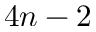<formula> <loc_0><loc_0><loc_500><loc_500>4 n - 2</formula> 